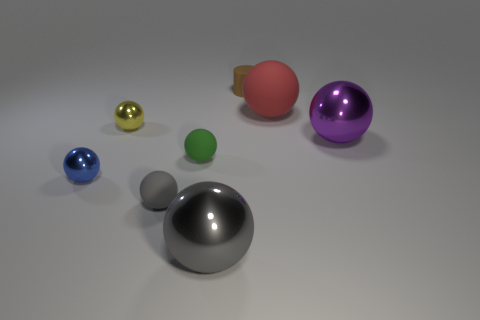There is a small thing in front of the tiny blue object; does it have the same color as the big sphere to the left of the large red rubber ball?
Ensure brevity in your answer.  Yes. Is the big thing that is in front of the large purple sphere made of the same material as the small green thing on the left side of the large rubber thing?
Keep it short and to the point. No. There is a shiny sphere that is to the left of the small yellow shiny thing; what size is it?
Offer a very short reply. Small. There is a big red thing that is the same shape as the large purple metallic thing; what material is it?
Provide a succinct answer. Rubber. The tiny thing that is right of the big gray sphere has what shape?
Provide a succinct answer. Cylinder. What number of other shiny objects have the same shape as the tiny yellow object?
Your answer should be very brief. 3. Is the number of purple metal balls that are in front of the gray shiny thing the same as the number of balls that are to the right of the tiny green matte object?
Give a very brief answer. No. Is there a big brown cylinder that has the same material as the large red object?
Your response must be concise. No. Are the red ball and the tiny yellow ball made of the same material?
Offer a very short reply. No. What number of brown things are either small matte cylinders or large cubes?
Make the answer very short. 1. 